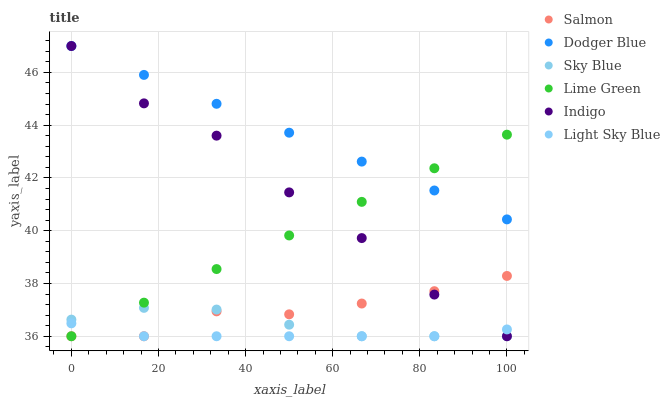Does Light Sky Blue have the minimum area under the curve?
Answer yes or no. Yes. Does Dodger Blue have the maximum area under the curve?
Answer yes or no. Yes. Does Salmon have the minimum area under the curve?
Answer yes or no. No. Does Salmon have the maximum area under the curve?
Answer yes or no. No. Is Lime Green the smoothest?
Answer yes or no. Yes. Is Indigo the roughest?
Answer yes or no. Yes. Is Salmon the smoothest?
Answer yes or no. No. Is Salmon the roughest?
Answer yes or no. No. Does Indigo have the lowest value?
Answer yes or no. Yes. Does Dodger Blue have the lowest value?
Answer yes or no. No. Does Dodger Blue have the highest value?
Answer yes or no. Yes. Does Salmon have the highest value?
Answer yes or no. No. Is Salmon less than Dodger Blue?
Answer yes or no. Yes. Is Dodger Blue greater than Light Sky Blue?
Answer yes or no. Yes. Does Dodger Blue intersect Lime Green?
Answer yes or no. Yes. Is Dodger Blue less than Lime Green?
Answer yes or no. No. Is Dodger Blue greater than Lime Green?
Answer yes or no. No. Does Salmon intersect Dodger Blue?
Answer yes or no. No. 